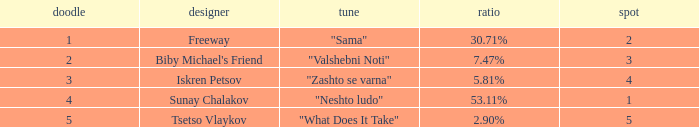What is the least draw when the place is higher than 4? 5.0. 